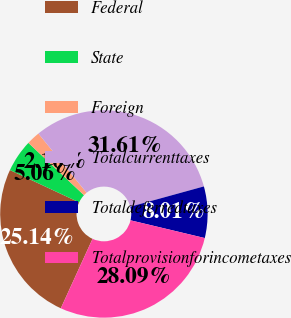Convert chart. <chart><loc_0><loc_0><loc_500><loc_500><pie_chart><fcel>Federal<fcel>State<fcel>Foreign<fcel>Totalcurrenttaxes<fcel>Totaldeferredtaxes<fcel>Totalprovisionforincometaxes<nl><fcel>25.14%<fcel>5.06%<fcel>2.1%<fcel>31.61%<fcel>8.01%<fcel>28.09%<nl></chart> 